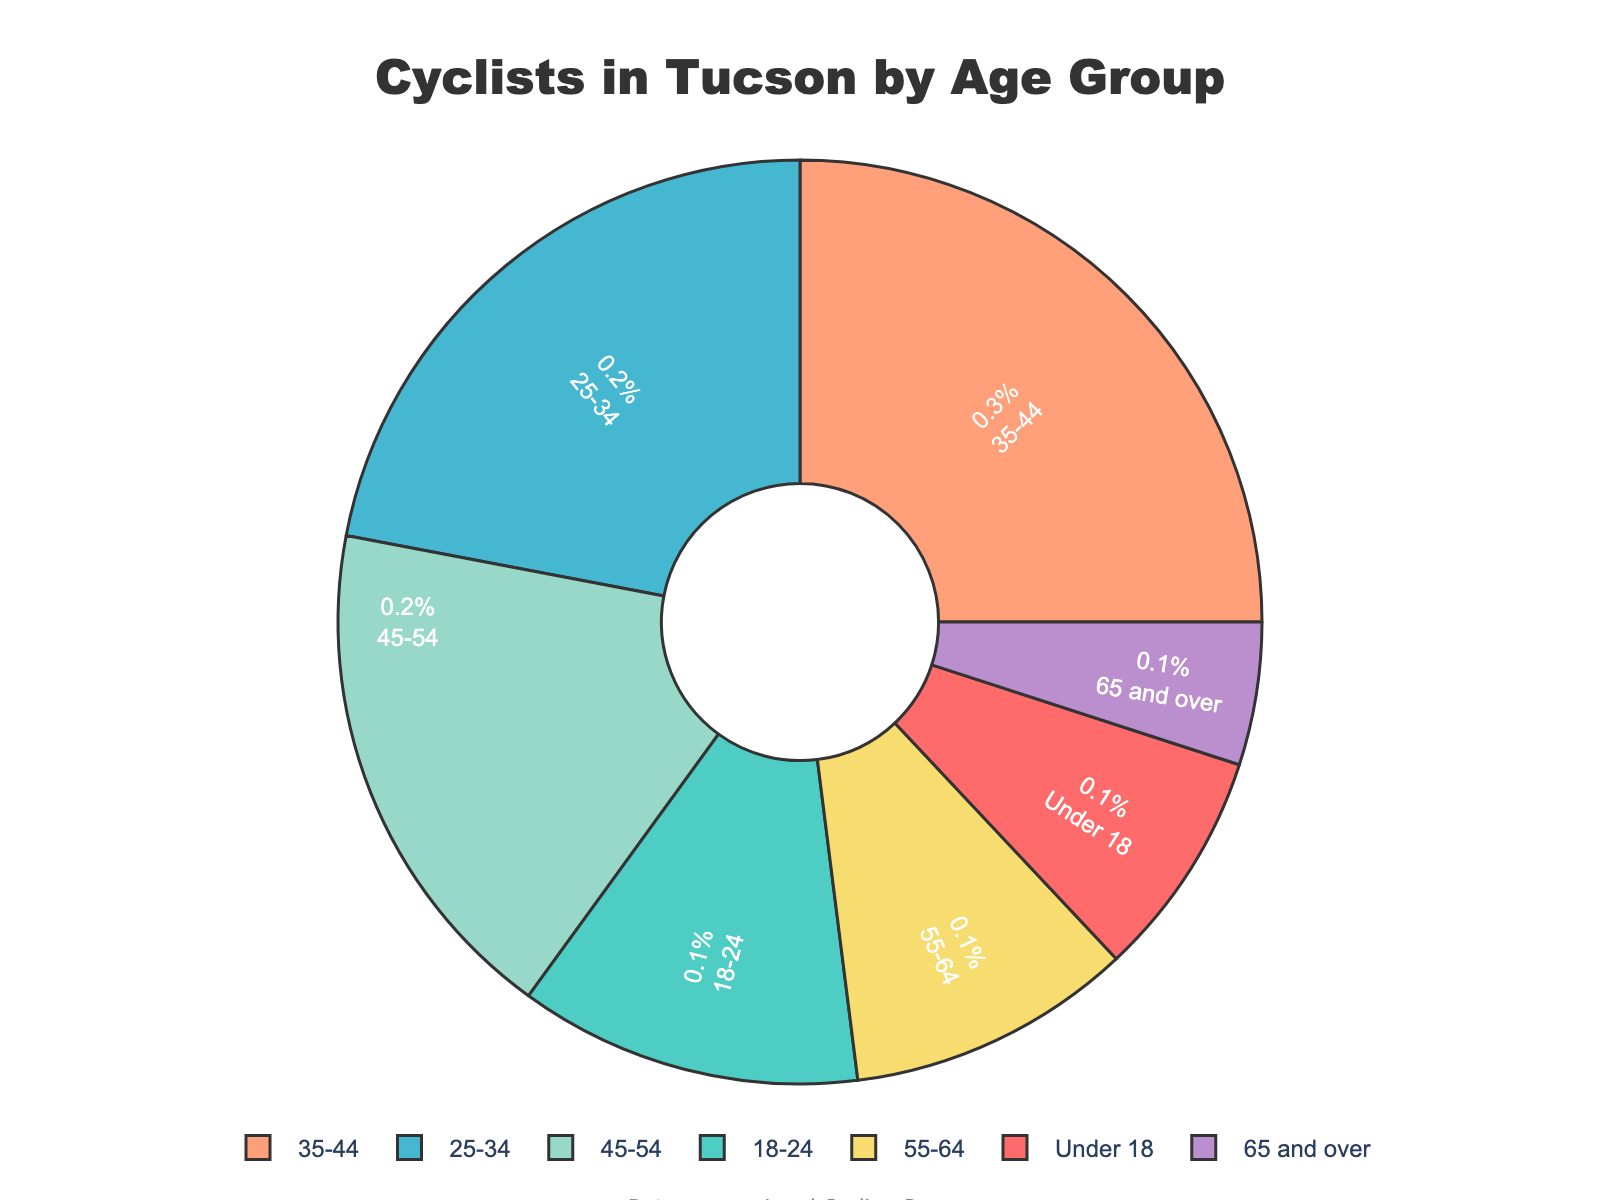What's the most represented age group among cyclists in Tucson? The age group with the highest percentage in the pie chart represents the most represented age group. The segment labeled 35-44 shows the highest percentage at 25%.
Answer: 35-44 Which age group has the least percentage of cyclists, and what is that percentage? To find the age group with the smallest percentage, look for the smallest segment in the pie chart. The segment labeled 65 and over has the smallest percentage at 5%.
Answer: 65 and over has 5% Calculate the combined percentage of cyclists who are 34 years old and younger. Add the percentages of the age groups Under 18, 18-24, and 25-34. The combined percentage is 8% + 12% + 22% = 42%.
Answer: 42% How does the percentage of cyclists aged 45-54 compare to those aged 55-64? Compare the percentage values of the two age groups. The percentage for 45-54 is 18%, while for 55-64, it is 10%. So, 45-54 has a higher percentage.
Answer: 45-54 has a higher percentage Are the combined percentage of cyclists under 18 and those 65 and over greater than the percentage of cyclists aged 18-24? Add the percentages for Under 18 (8%) and 65 and over (5%), which is 8% + 5% = 13%. Compare this with the percentage of 18-24, which is 12%. 13% is indeed greater than 12%.
Answer: Yes What percentage of cyclists are in the middle-aged (35-54) groups? Sum the percentages for the age groups 35-44 and 45-54. The combined percentage is 25% + 18% = 43%.
Answer: 43% Compare the percentage of cyclists aged 25-34 with the combined percentage of cyclists aged 55 and over. The percentage for 25-34 is 22%. The combined percentage for 55-64 (10%) and 65 and over (5%) is 15%. Therefore, 22% is greater than 15%.
Answer: 25-34 has a greater percentage Which two consecutive age groups combined have the highest percentage of cyclists? Check the combined percentages of consecutive age groups: 
- Under 18 + 18-24 = 8% + 12% = 20%
- 18-24 + 25-34 = 12% + 22% = 34%
- 25-34 + 35-44 = 22% + 25% = 47%
- 35-44 + 45-54 = 25% + 18% = 43%
- 45-54 + 55-64 = 18% + 10% = 28%
- 55-64 + 65 and over = 10% + 5% = 15%
The highest combined percentage is for 25-34 and 35-44 at 47%.
Answer: 25-34 and 35-44 If we group all the cyclists above 44 into one category, what would be their combined percentage? Sum the percentages for the age groups 45-54, 55-64, and 65 and over. The combined percentage is 18% + 10% + 5% = 33%.
Answer: 33% 